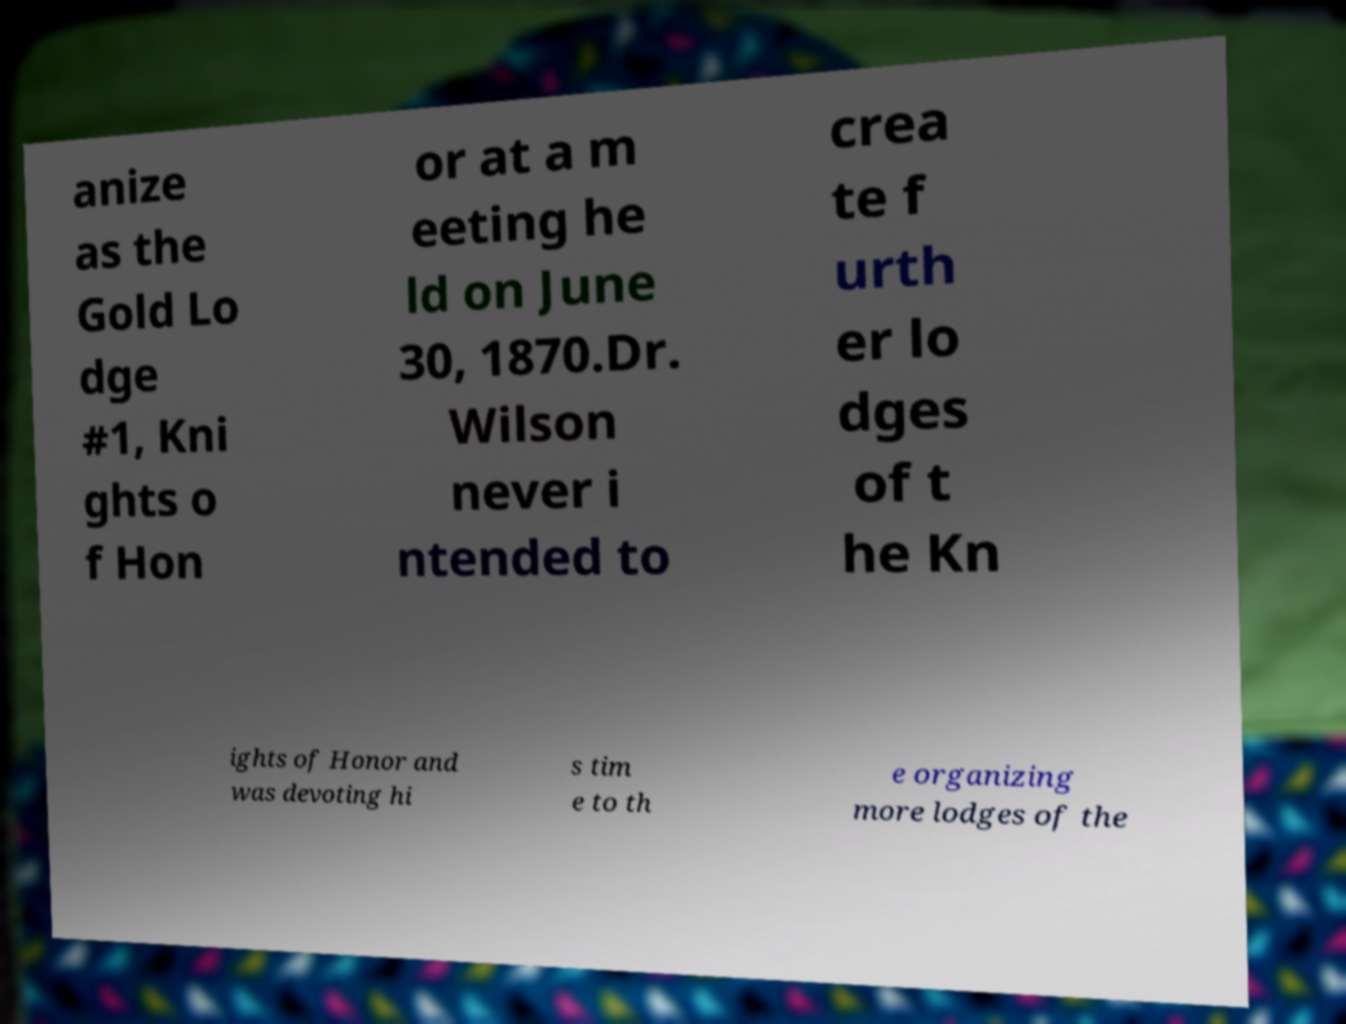Please identify and transcribe the text found in this image. anize as the Gold Lo dge #1, Kni ghts o f Hon or at a m eeting he ld on June 30, 1870.Dr. Wilson never i ntended to crea te f urth er lo dges of t he Kn ights of Honor and was devoting hi s tim e to th e organizing more lodges of the 